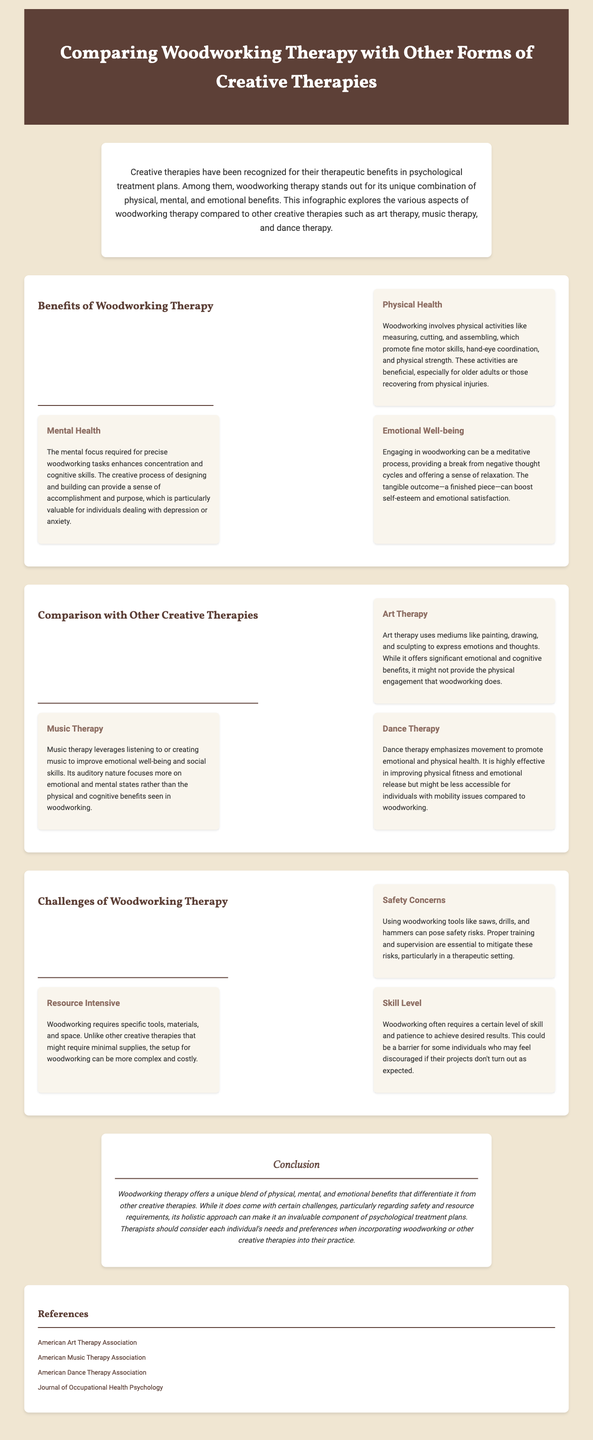what are the three main benefits of woodworking therapy? The benefits listed in the document are Physical Health, Mental Health, and Emotional Well-being.
Answer: Physical Health, Mental Health, Emotional Well-being how does woodworking compare to art therapy? Woodworking provides physical engagement, while art therapy focuses on emotional expression through mediums like painting.
Answer: Physical engagement what is a key challenge of woodworking therapy? One challenge highlighted is the safety concerns associated with using tools in woodworking.
Answer: Safety concerns which types of therapy focus more on emotional well-being? Music therapy and dance therapy both emphasize emotional well-being in their practices.
Answer: Music therapy, dance therapy what is required for woodworking to be safe? Proper training and supervision are essential to mitigate safety risks in woodworking therapy.
Answer: Training and supervision how many benefits of woodworking therapy are mentioned? The document outlines three benefits of woodworking therapy.
Answer: Three what is one resource-related challenge of woodworking therapy? Woodworking can be resource-intensive due to the specific tools, materials, and space required.
Answer: Resource intensive what emotional outcome is linked to completing a woodworking project? A finished piece can boost self-esteem and emotional satisfaction.
Answer: Self-esteem and emotional satisfaction 